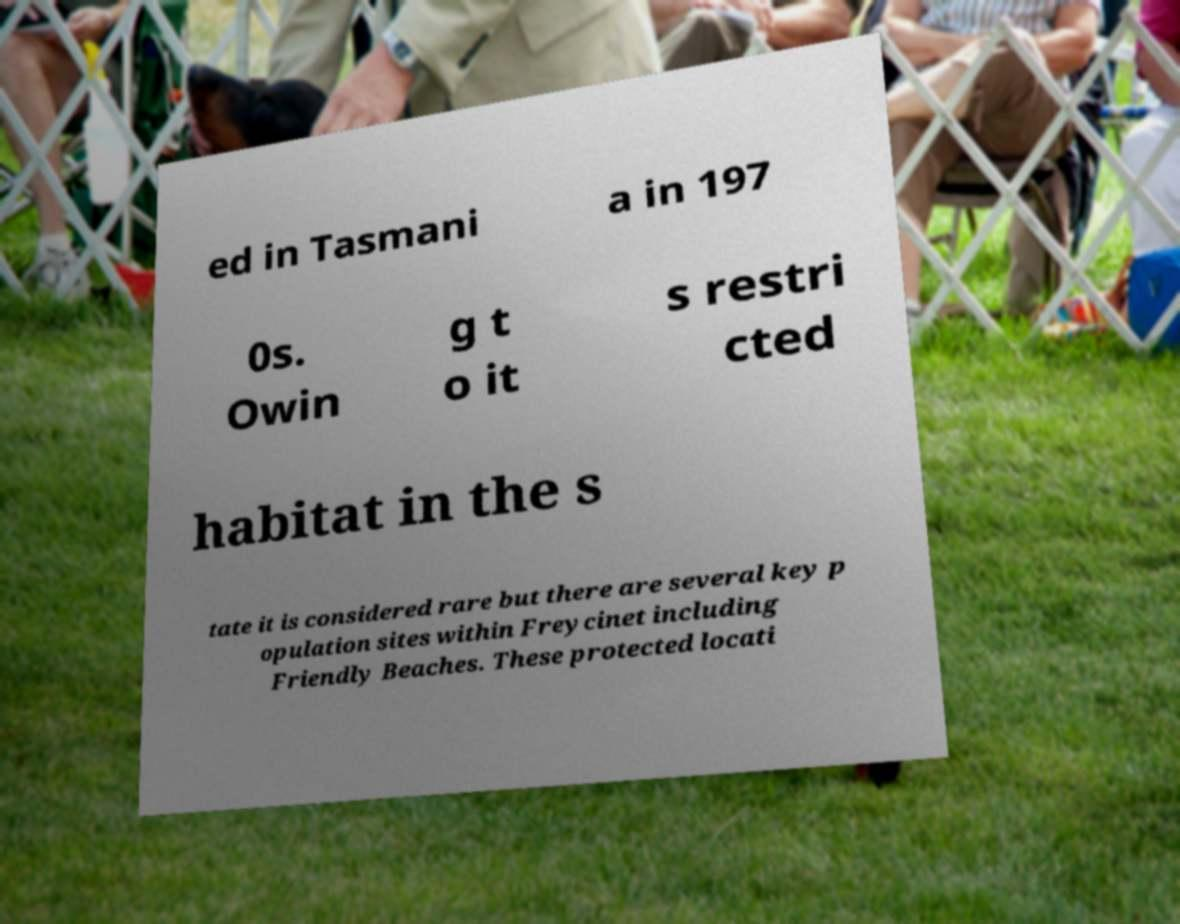Please identify and transcribe the text found in this image. ed in Tasmani a in 197 0s. Owin g t o it s restri cted habitat in the s tate it is considered rare but there are several key p opulation sites within Freycinet including Friendly Beaches. These protected locati 